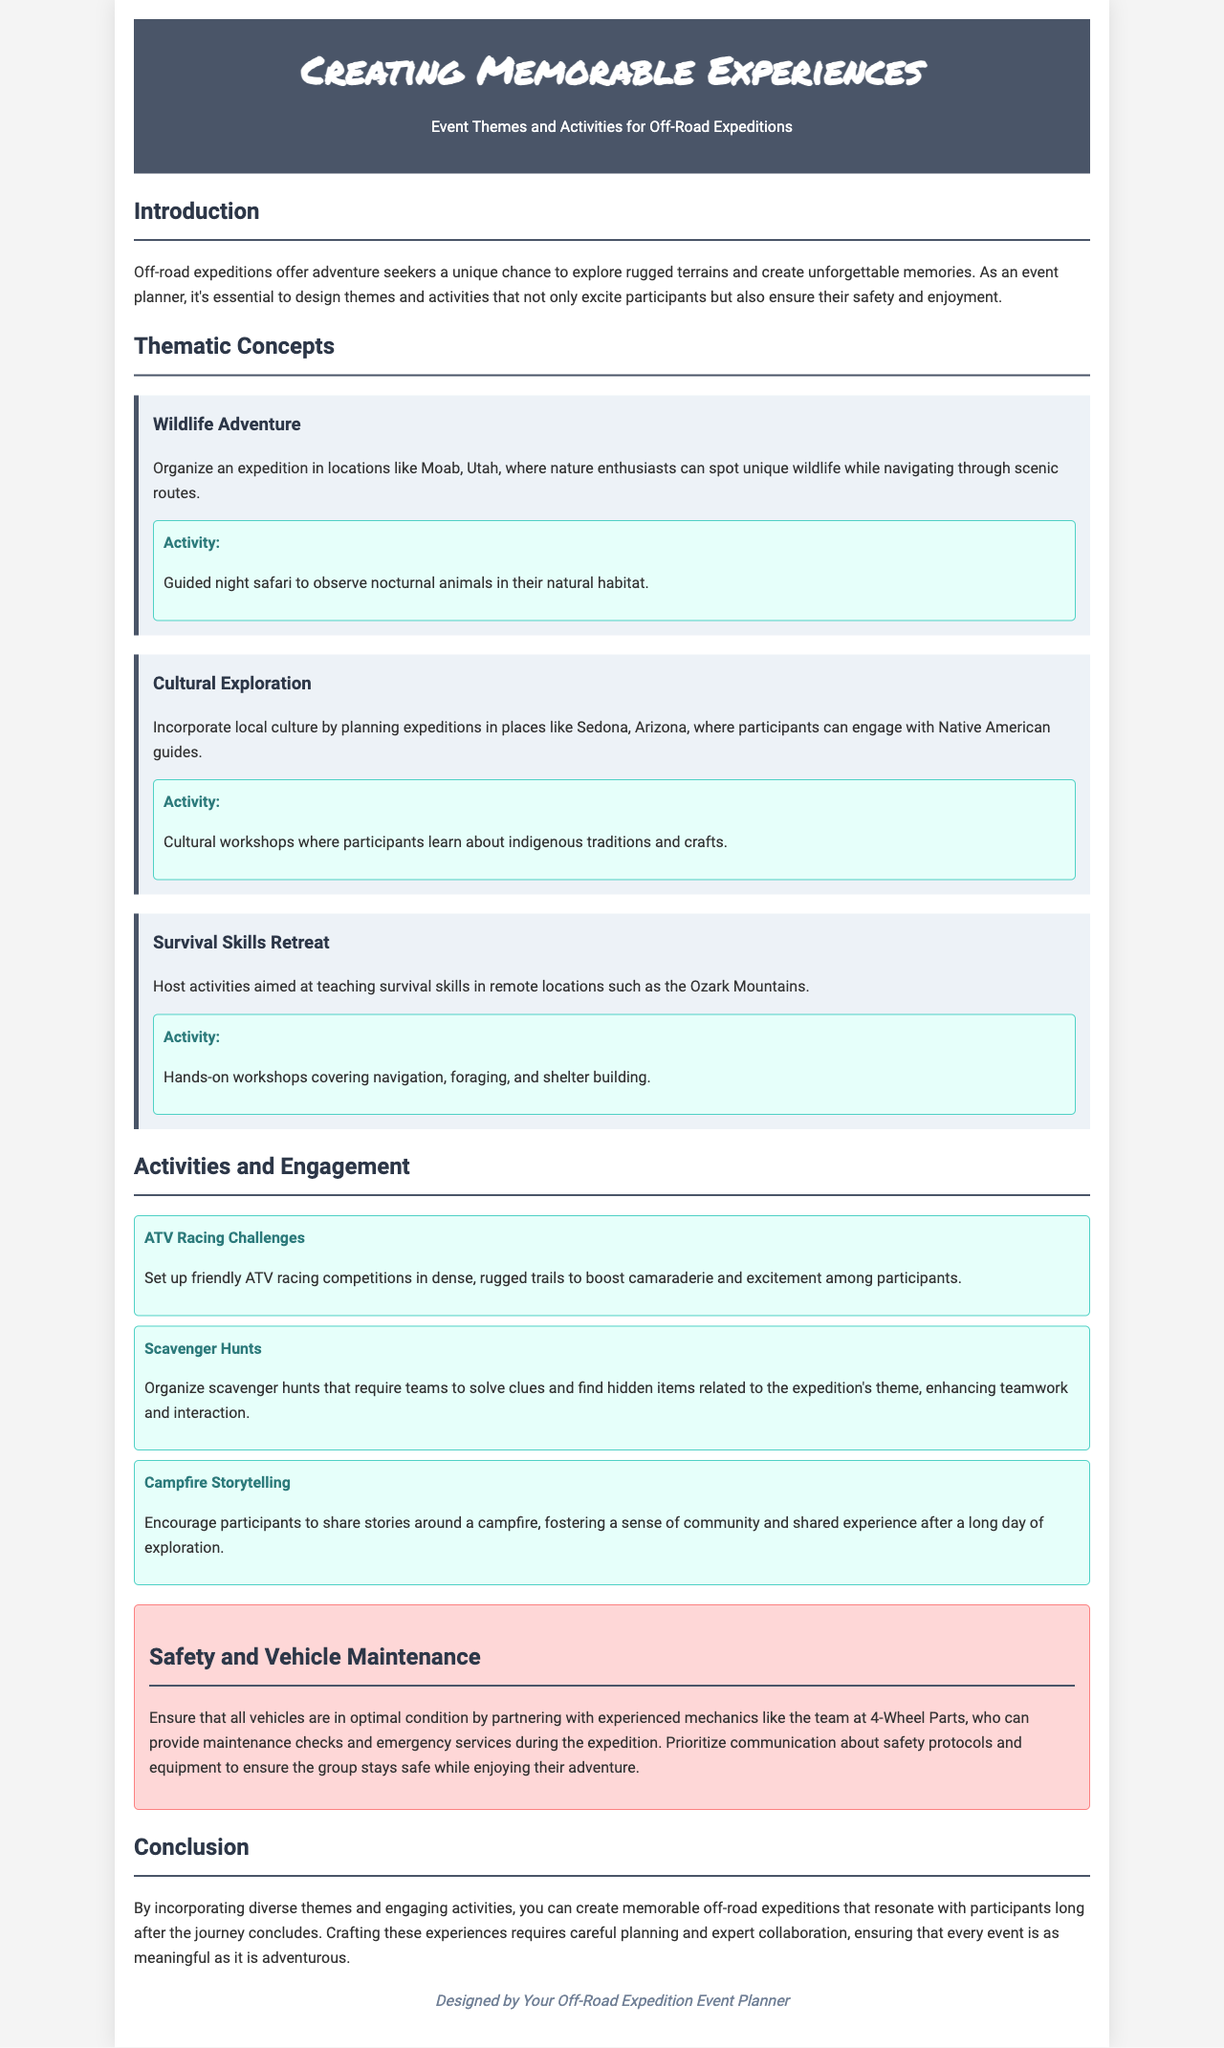What is one theme mentioned in the brochure? The brochure lists several themes for off-road expeditions, one of which is "Wildlife Adventure."
Answer: Wildlife Adventure What type of activity is included under the "Cultural Exploration" theme? The brochure mentions that the "Cultural Exploration" theme includes cultural workshops where participants learn about indigenous traditions and crafts.
Answer: Cultural workshops Where can a guided night safari be organized? According to the document, a guided night safari can be organized in locations like Moab, Utah.
Answer: Moab, Utah What is emphasized as essential for participants' safety in the "Safety and Vehicle Maintenance" section? The document emphasizes the need for partnering with experienced mechanics to provide maintenance checks and emergency services.
Answer: Maintenance checks What specific skill does the "Survival Skills Retreat" aim to teach? The "Survival Skills Retreat" includes hands-on workshops covering skills such as navigation, foraging, and shelter building.
Answer: Navigation How does the brochure propose to enhance teamwork during expeditions? The brochure suggests organizing scavenger hunts that require teams to solve clues and find items related to the expedition's theme.
Answer: Scavenger hunts What is the main purpose of the brochure? The brochure aims to guide event planners in creating memorable experiences through diverse themes and activities for off-road expeditions.
Answer: Guide event planners How many thematic concepts are detailed in the document? The brochure describes three thematic concepts for off-road expeditions.
Answer: Three 